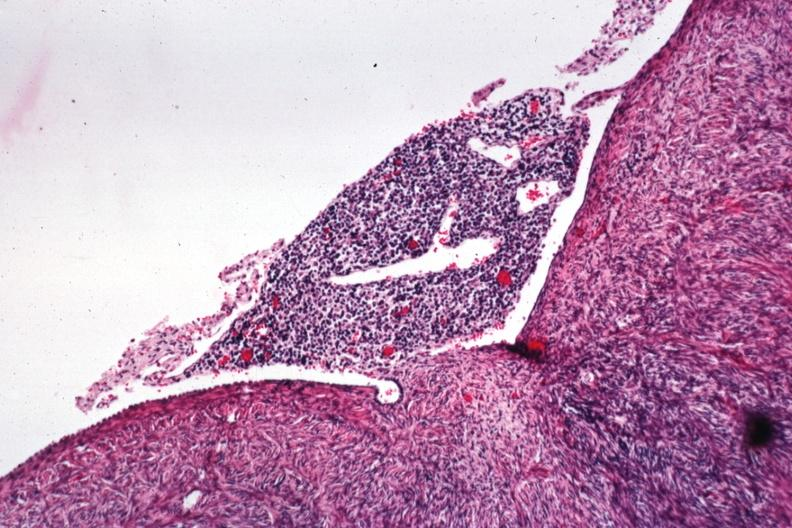does lymphangiomatosis generalized show lymphocytic infiltrate on peritoneal surface?
Answer the question using a single word or phrase. No 